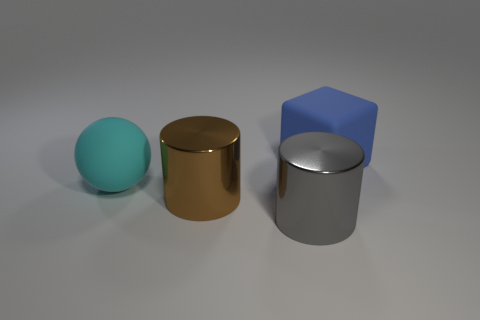Add 3 big matte blocks. How many objects exist? 7 Subtract all balls. How many objects are left? 3 Add 3 blocks. How many blocks exist? 4 Subtract 0 green cylinders. How many objects are left? 4 Subtract all big red metal cylinders. Subtract all big blue objects. How many objects are left? 3 Add 3 blocks. How many blocks are left? 4 